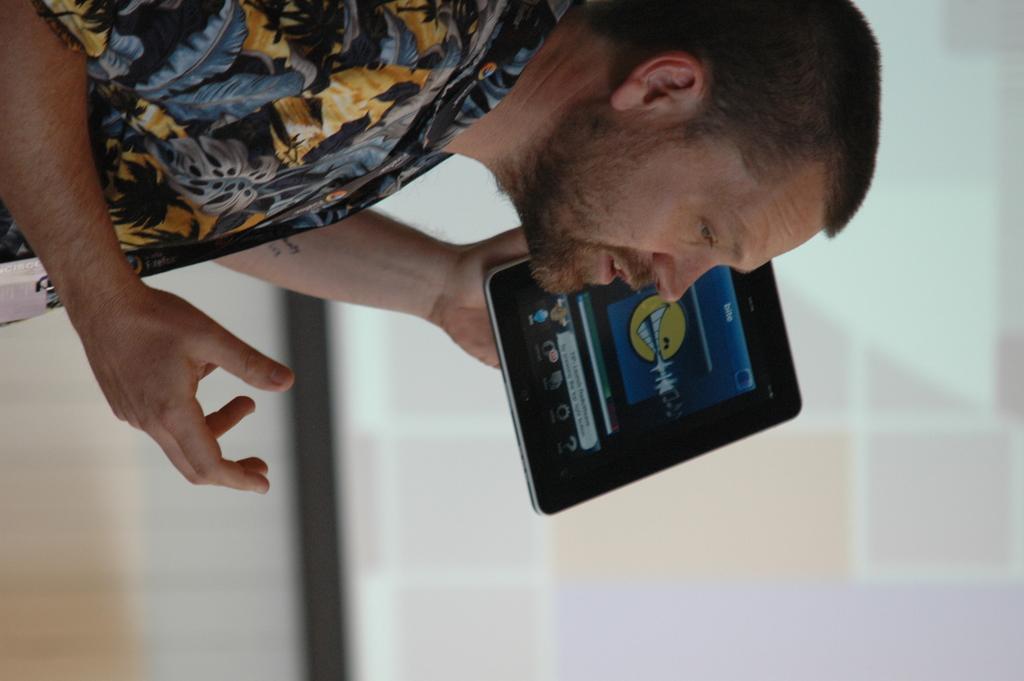In one or two sentences, can you explain what this image depicts? In this image at the top we can see a man is holding a tab in his hand and in the background the image is blur but we can see the screen. 